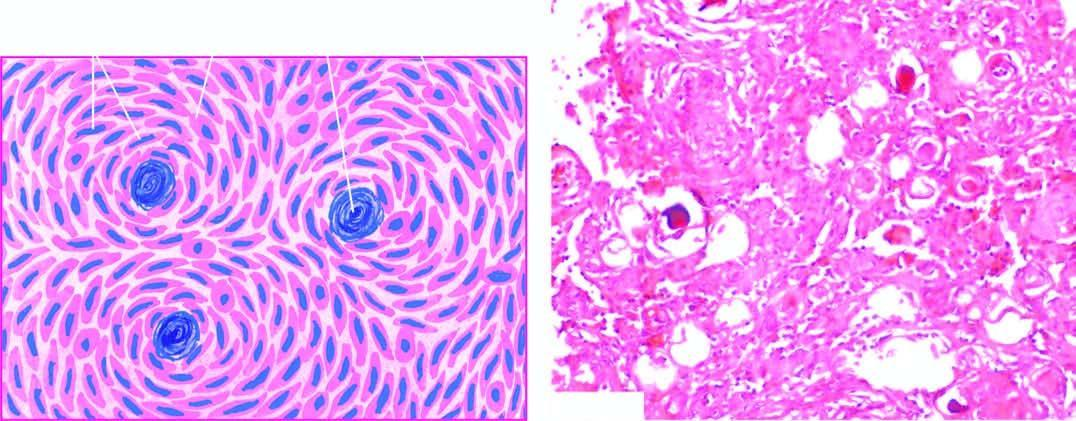what have features of both syncytial and fibroblastic type and form whorled appearance?
Answer the question using a single word or phrase. Cells 